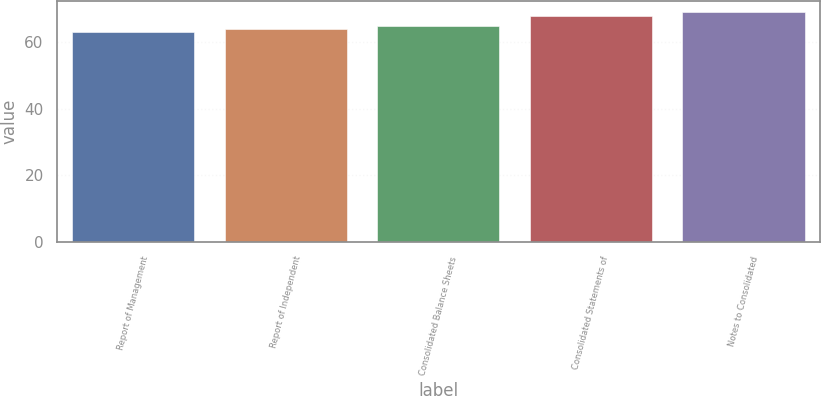<chart> <loc_0><loc_0><loc_500><loc_500><bar_chart><fcel>Report of Management<fcel>Report of Independent<fcel>Consolidated Balance Sheets<fcel>Consolidated Statements of<fcel>Notes to Consolidated<nl><fcel>63<fcel>64<fcel>65<fcel>68<fcel>69<nl></chart> 